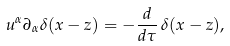Convert formula to latex. <formula><loc_0><loc_0><loc_500><loc_500>u ^ { \alpha } \partial _ { \alpha } \delta ( x - z ) = - \frac { d } { d \tau } \, \delta ( x - z ) ,</formula> 